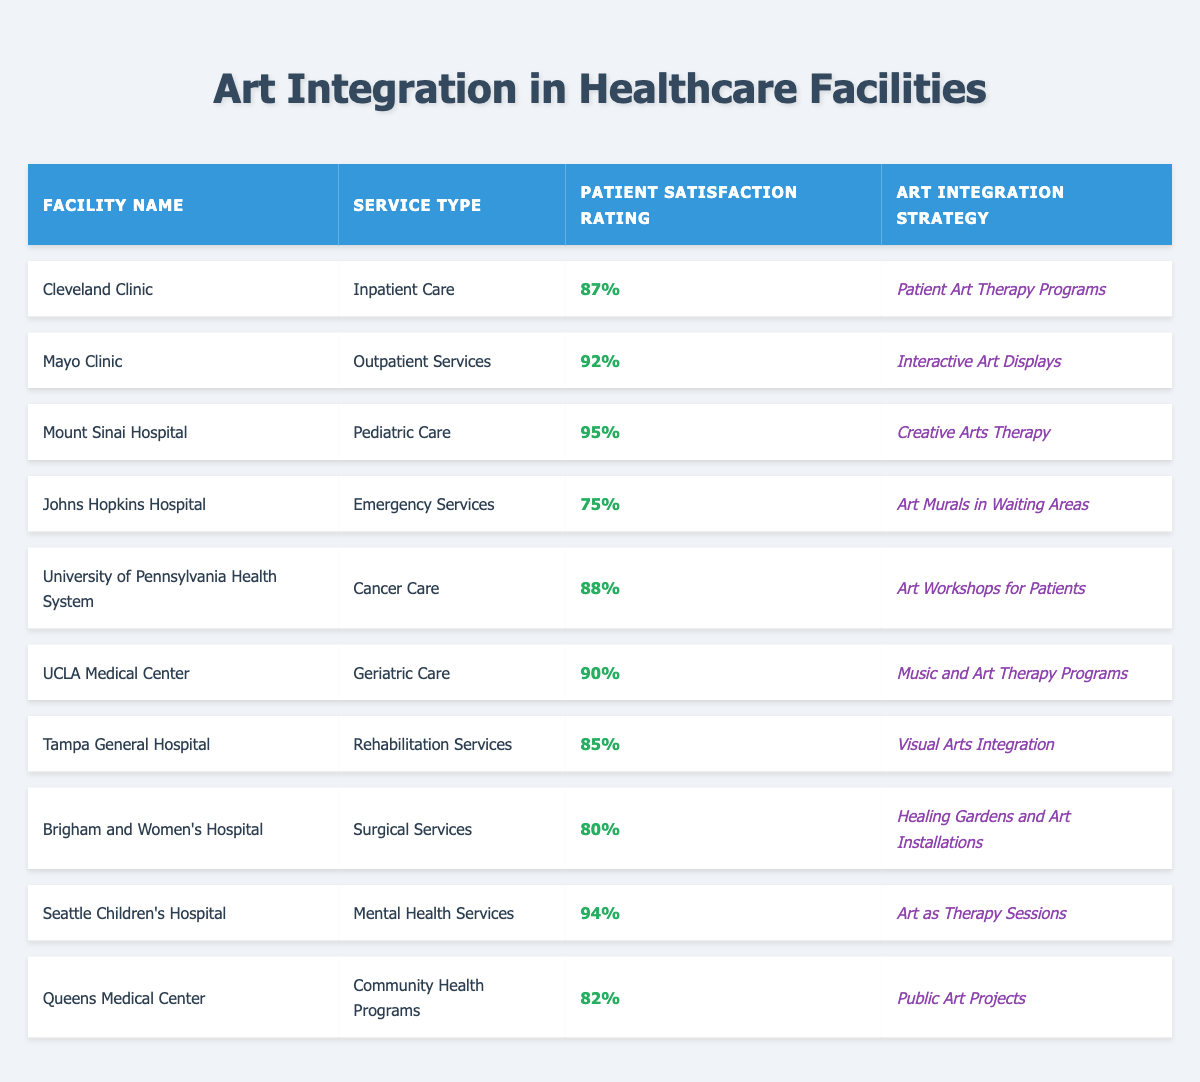What is the patient satisfaction rating for Mount Sinai Hospital? The table lists Mount Sinai Hospital under Pediatric Care with a patient satisfaction rating of 95%.
Answer: 95% Which facility has the highest patient satisfaction rating? The table shows that Mount Sinai Hospital has the highest rating of 95% compared to all other facilities listed.
Answer: Mount Sinai Hospital What art integration strategy is used at Johns Hopkins Hospital? The table indicates that Johns Hopkins Hospital uses "Art Murals in Waiting Areas" as their art integration strategy.
Answer: Art Murals in Waiting Areas How many facilities have a patient satisfaction rating above 90%? From the table, Mount Sinai Hospital, Mayo Clinic, and Seattle Children's Hospital have ratings of 95%, 92%, and 94% respectively, totaling three facilities above 90%.
Answer: 3 Is the patient satisfaction rating for Cleveland Clinic higher than that of Brigham and Women's Hospital? The table shows Cleveland Clinic has a rating of 87%, while Brigham and Women’s Hospital has a rating of 80%. Therefore, yes, Cleveland Clinic's rating is higher.
Answer: Yes What is the average patient satisfaction rating of the facilities that focus on Mental Health Services? According to the table, only Seattle Children's Hospital focuses on Mental Health Services with a patient satisfaction rating of 94%, so the average is the same as their rating.
Answer: 94% List the art integration strategies for the facility with the lowest patient satisfaction rating. Johns Hopkins Hospital has the lowest patient satisfaction rating of 75%, and its strategy is "Art Murals in Waiting Areas."
Answer: Art Murals in Waiting Areas What percentage difference is there between the highest and lowest patient satisfaction ratings? The highest rating is 95% from Mount Sinai Hospital and the lowest is 75% from Johns Hopkins Hospital. The difference is 95% - 75% = 20%.
Answer: 20% Which healthcare facility offers Music and Art Therapy Programs? The table indicates that UCLA Medical Center provides Music and Art Therapy Programs as an art integration strategy.
Answer: UCLA Medical Center Do all facilities listed have a patient satisfaction rating above 80%? The facilities listed have ratings of 95%, 92%, 94%, 90%, 88%, 87%, 85%, 82%, 80%, and 75%. Since Johns Hopkins Hospital has a rating of 75%, not all do.
Answer: No 